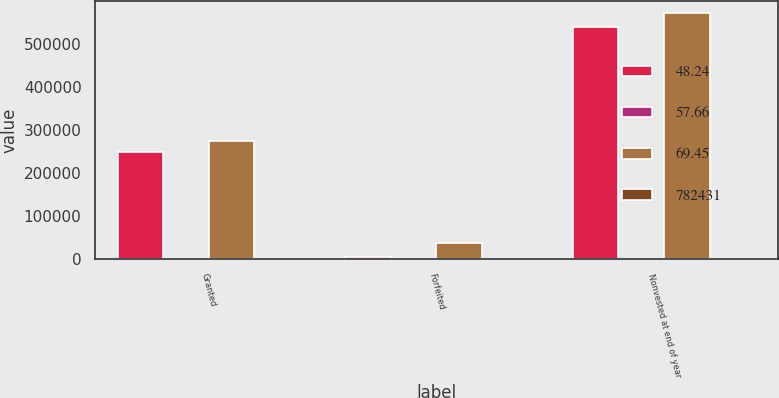Convert chart to OTSL. <chart><loc_0><loc_0><loc_500><loc_500><stacked_bar_chart><ecel><fcel>Granted<fcel>Forfeited<fcel>Nonvested at end of year<nl><fcel>48.24<fcel>248710<fcel>6540<fcel>538592<nl><fcel>57.66<fcel>85.62<fcel>74.87<fcel>80.91<nl><fcel>69.45<fcel>273497<fcel>36788<fcel>570814<nl><fcel>782431<fcel>74.15<fcel>63.48<fcel>69.45<nl></chart> 